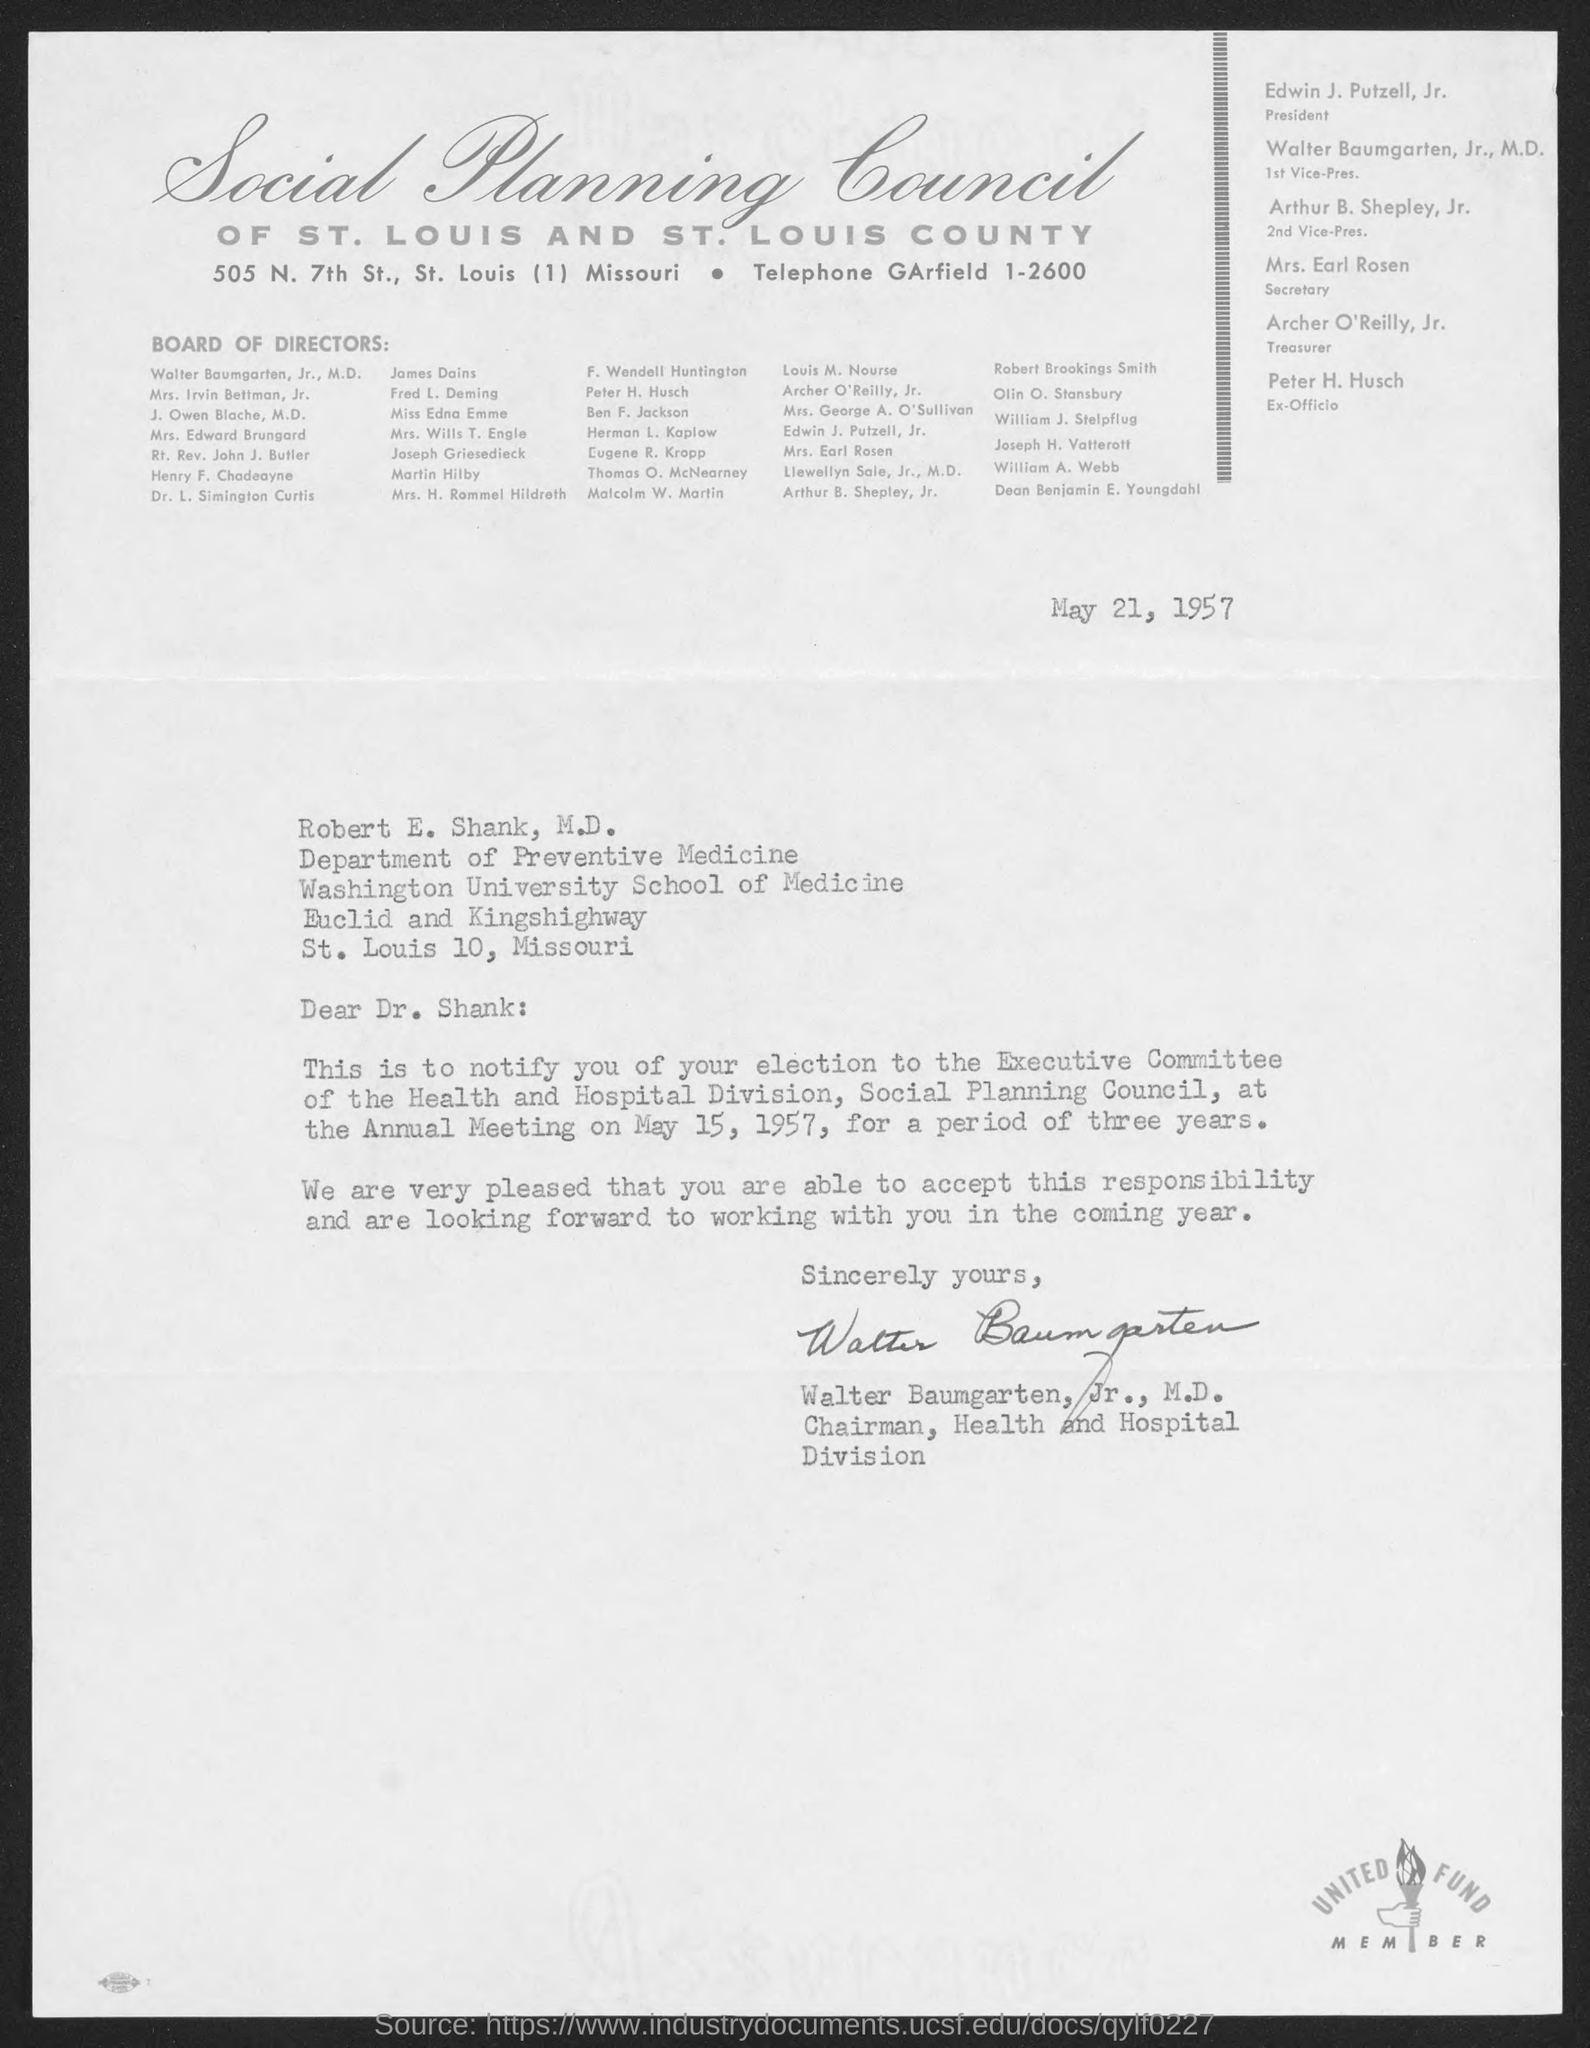What is the date on the document?
Your answer should be compact. May 21, 1957. To Whom is this letter addressed to?
Your response must be concise. Robert E. Shank, M.D. Who is this letter from?
Your answer should be compact. Walter Baumgarten, Jr., M.D. When is the annual meeting?
Your answer should be compact. May 15, 1957. 